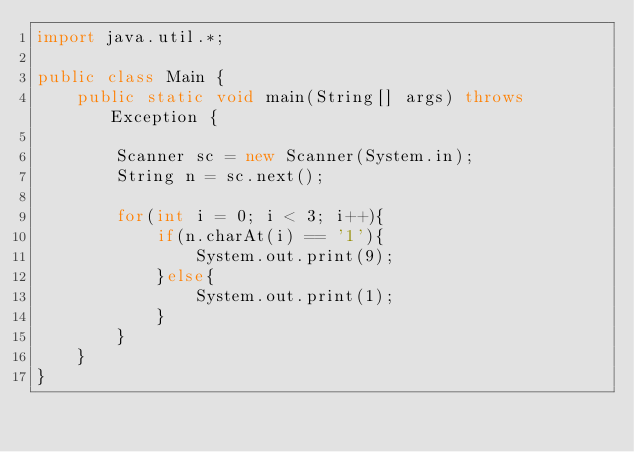<code> <loc_0><loc_0><loc_500><loc_500><_Java_>import java.util.*;

public class Main {
    public static void main(String[] args) throws Exception {
        
        Scanner sc = new Scanner(System.in);
        String n = sc.next();
        
        for(int i = 0; i < 3; i++){
            if(n.charAt(i) == '1'){
                System.out.print(9);
            }else{
                System.out.print(1);
            }
        }
    }
}
</code> 